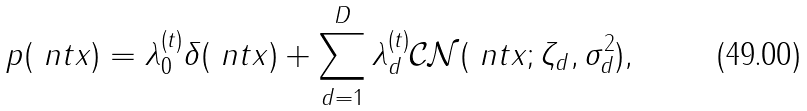Convert formula to latex. <formula><loc_0><loc_0><loc_500><loc_500>p ( \ n t { x } ) = \lambda _ { 0 } ^ { ( t ) } \delta ( \ n t { x } ) + \sum _ { d = 1 } ^ { D } \lambda _ { d } ^ { ( t ) } \mathcal { C N } ( \ n t { x } ; \zeta _ { d } , \sigma _ { d } ^ { 2 } ) ,</formula> 